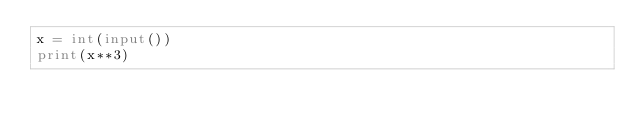Convert code to text. <code><loc_0><loc_0><loc_500><loc_500><_Python_>x = int(input())
print(x**3)</code> 